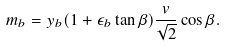Convert formula to latex. <formula><loc_0><loc_0><loc_500><loc_500>m _ { b } = y _ { b } ( 1 + \epsilon _ { b } \tan { \beta } ) \frac { v } { \sqrt { 2 } } \cos { \beta } .</formula> 